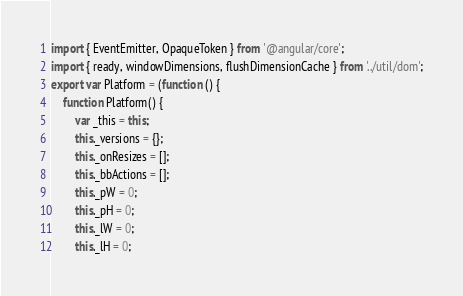<code> <loc_0><loc_0><loc_500><loc_500><_JavaScript_>import { EventEmitter, OpaqueToken } from '@angular/core';
import { ready, windowDimensions, flushDimensionCache } from '../util/dom';
export var Platform = (function () {
    function Platform() {
        var _this = this;
        this._versions = {};
        this._onResizes = [];
        this._bbActions = [];
        this._pW = 0;
        this._pH = 0;
        this._lW = 0;
        this._lH = 0;</code> 